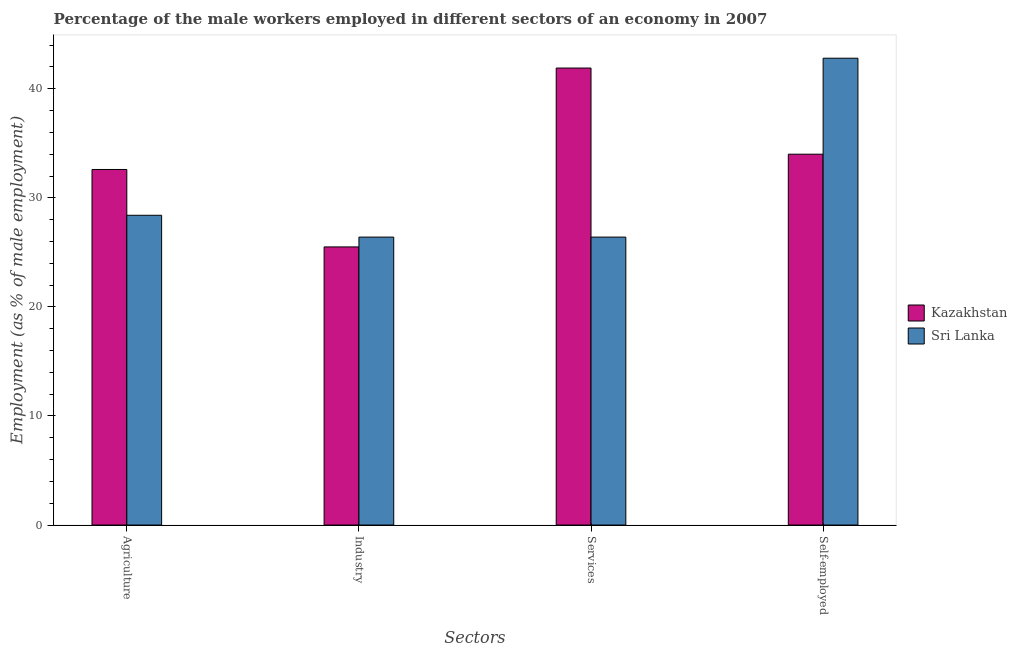Are the number of bars per tick equal to the number of legend labels?
Ensure brevity in your answer.  Yes. Are the number of bars on each tick of the X-axis equal?
Offer a very short reply. Yes. How many bars are there on the 2nd tick from the right?
Your answer should be very brief. 2. What is the label of the 2nd group of bars from the left?
Offer a very short reply. Industry. What is the percentage of male workers in industry in Sri Lanka?
Your answer should be very brief. 26.4. Across all countries, what is the maximum percentage of male workers in industry?
Your answer should be compact. 26.4. Across all countries, what is the minimum percentage of male workers in services?
Keep it short and to the point. 26.4. In which country was the percentage of self employed male workers maximum?
Give a very brief answer. Sri Lanka. In which country was the percentage of male workers in services minimum?
Make the answer very short. Sri Lanka. What is the total percentage of male workers in industry in the graph?
Offer a very short reply. 51.9. What is the difference between the percentage of male workers in services in Sri Lanka and that in Kazakhstan?
Your response must be concise. -15.5. What is the difference between the percentage of male workers in services in Sri Lanka and the percentage of male workers in agriculture in Kazakhstan?
Your response must be concise. -6.2. What is the average percentage of male workers in industry per country?
Offer a very short reply. 25.95. What is the difference between the percentage of self employed male workers and percentage of male workers in services in Kazakhstan?
Keep it short and to the point. -7.9. In how many countries, is the percentage of male workers in agriculture greater than 28 %?
Provide a succinct answer. 2. What is the ratio of the percentage of male workers in services in Sri Lanka to that in Kazakhstan?
Offer a very short reply. 0.63. Is the difference between the percentage of male workers in agriculture in Kazakhstan and Sri Lanka greater than the difference between the percentage of male workers in industry in Kazakhstan and Sri Lanka?
Your answer should be very brief. Yes. What is the difference between the highest and the second highest percentage of self employed male workers?
Give a very brief answer. 8.8. What is the difference between the highest and the lowest percentage of male workers in agriculture?
Offer a terse response. 4.2. Is the sum of the percentage of male workers in industry in Sri Lanka and Kazakhstan greater than the maximum percentage of self employed male workers across all countries?
Your answer should be compact. Yes. What does the 2nd bar from the left in Services represents?
Offer a terse response. Sri Lanka. What does the 2nd bar from the right in Industry represents?
Offer a terse response. Kazakhstan. Is it the case that in every country, the sum of the percentage of male workers in agriculture and percentage of male workers in industry is greater than the percentage of male workers in services?
Keep it short and to the point. Yes. Are all the bars in the graph horizontal?
Offer a very short reply. No. How many countries are there in the graph?
Your answer should be compact. 2. What is the difference between two consecutive major ticks on the Y-axis?
Give a very brief answer. 10. Are the values on the major ticks of Y-axis written in scientific E-notation?
Give a very brief answer. No. Does the graph contain any zero values?
Your response must be concise. No. What is the title of the graph?
Keep it short and to the point. Percentage of the male workers employed in different sectors of an economy in 2007. What is the label or title of the X-axis?
Offer a very short reply. Sectors. What is the label or title of the Y-axis?
Your response must be concise. Employment (as % of male employment). What is the Employment (as % of male employment) in Kazakhstan in Agriculture?
Your answer should be very brief. 32.6. What is the Employment (as % of male employment) in Sri Lanka in Agriculture?
Provide a succinct answer. 28.4. What is the Employment (as % of male employment) in Kazakhstan in Industry?
Provide a succinct answer. 25.5. What is the Employment (as % of male employment) of Sri Lanka in Industry?
Make the answer very short. 26.4. What is the Employment (as % of male employment) of Kazakhstan in Services?
Offer a terse response. 41.9. What is the Employment (as % of male employment) in Sri Lanka in Services?
Your response must be concise. 26.4. What is the Employment (as % of male employment) in Sri Lanka in Self-employed?
Ensure brevity in your answer.  42.8. Across all Sectors, what is the maximum Employment (as % of male employment) in Kazakhstan?
Keep it short and to the point. 41.9. Across all Sectors, what is the maximum Employment (as % of male employment) in Sri Lanka?
Your response must be concise. 42.8. Across all Sectors, what is the minimum Employment (as % of male employment) in Kazakhstan?
Offer a very short reply. 25.5. Across all Sectors, what is the minimum Employment (as % of male employment) of Sri Lanka?
Make the answer very short. 26.4. What is the total Employment (as % of male employment) in Kazakhstan in the graph?
Your answer should be compact. 134. What is the total Employment (as % of male employment) of Sri Lanka in the graph?
Your answer should be very brief. 124. What is the difference between the Employment (as % of male employment) in Sri Lanka in Agriculture and that in Industry?
Offer a very short reply. 2. What is the difference between the Employment (as % of male employment) in Kazakhstan in Agriculture and that in Self-employed?
Your answer should be compact. -1.4. What is the difference between the Employment (as % of male employment) in Sri Lanka in Agriculture and that in Self-employed?
Your response must be concise. -14.4. What is the difference between the Employment (as % of male employment) in Kazakhstan in Industry and that in Services?
Make the answer very short. -16.4. What is the difference between the Employment (as % of male employment) of Sri Lanka in Industry and that in Services?
Keep it short and to the point. 0. What is the difference between the Employment (as % of male employment) of Kazakhstan in Industry and that in Self-employed?
Provide a short and direct response. -8.5. What is the difference between the Employment (as % of male employment) of Sri Lanka in Industry and that in Self-employed?
Your answer should be very brief. -16.4. What is the difference between the Employment (as % of male employment) of Sri Lanka in Services and that in Self-employed?
Your answer should be very brief. -16.4. What is the difference between the Employment (as % of male employment) in Kazakhstan in Agriculture and the Employment (as % of male employment) in Sri Lanka in Industry?
Provide a short and direct response. 6.2. What is the difference between the Employment (as % of male employment) of Kazakhstan in Agriculture and the Employment (as % of male employment) of Sri Lanka in Services?
Offer a terse response. 6.2. What is the difference between the Employment (as % of male employment) of Kazakhstan in Agriculture and the Employment (as % of male employment) of Sri Lanka in Self-employed?
Provide a succinct answer. -10.2. What is the difference between the Employment (as % of male employment) in Kazakhstan in Industry and the Employment (as % of male employment) in Sri Lanka in Self-employed?
Your answer should be compact. -17.3. What is the average Employment (as % of male employment) of Kazakhstan per Sectors?
Give a very brief answer. 33.5. What is the difference between the Employment (as % of male employment) of Kazakhstan and Employment (as % of male employment) of Sri Lanka in Industry?
Offer a very short reply. -0.9. What is the difference between the Employment (as % of male employment) of Kazakhstan and Employment (as % of male employment) of Sri Lanka in Services?
Give a very brief answer. 15.5. What is the ratio of the Employment (as % of male employment) in Kazakhstan in Agriculture to that in Industry?
Your answer should be very brief. 1.28. What is the ratio of the Employment (as % of male employment) in Sri Lanka in Agriculture to that in Industry?
Your answer should be compact. 1.08. What is the ratio of the Employment (as % of male employment) in Kazakhstan in Agriculture to that in Services?
Make the answer very short. 0.78. What is the ratio of the Employment (as % of male employment) in Sri Lanka in Agriculture to that in Services?
Offer a very short reply. 1.08. What is the ratio of the Employment (as % of male employment) in Kazakhstan in Agriculture to that in Self-employed?
Keep it short and to the point. 0.96. What is the ratio of the Employment (as % of male employment) of Sri Lanka in Agriculture to that in Self-employed?
Offer a very short reply. 0.66. What is the ratio of the Employment (as % of male employment) of Kazakhstan in Industry to that in Services?
Offer a very short reply. 0.61. What is the ratio of the Employment (as % of male employment) in Sri Lanka in Industry to that in Services?
Offer a terse response. 1. What is the ratio of the Employment (as % of male employment) in Kazakhstan in Industry to that in Self-employed?
Your answer should be compact. 0.75. What is the ratio of the Employment (as % of male employment) of Sri Lanka in Industry to that in Self-employed?
Offer a terse response. 0.62. What is the ratio of the Employment (as % of male employment) of Kazakhstan in Services to that in Self-employed?
Your response must be concise. 1.23. What is the ratio of the Employment (as % of male employment) in Sri Lanka in Services to that in Self-employed?
Ensure brevity in your answer.  0.62. 